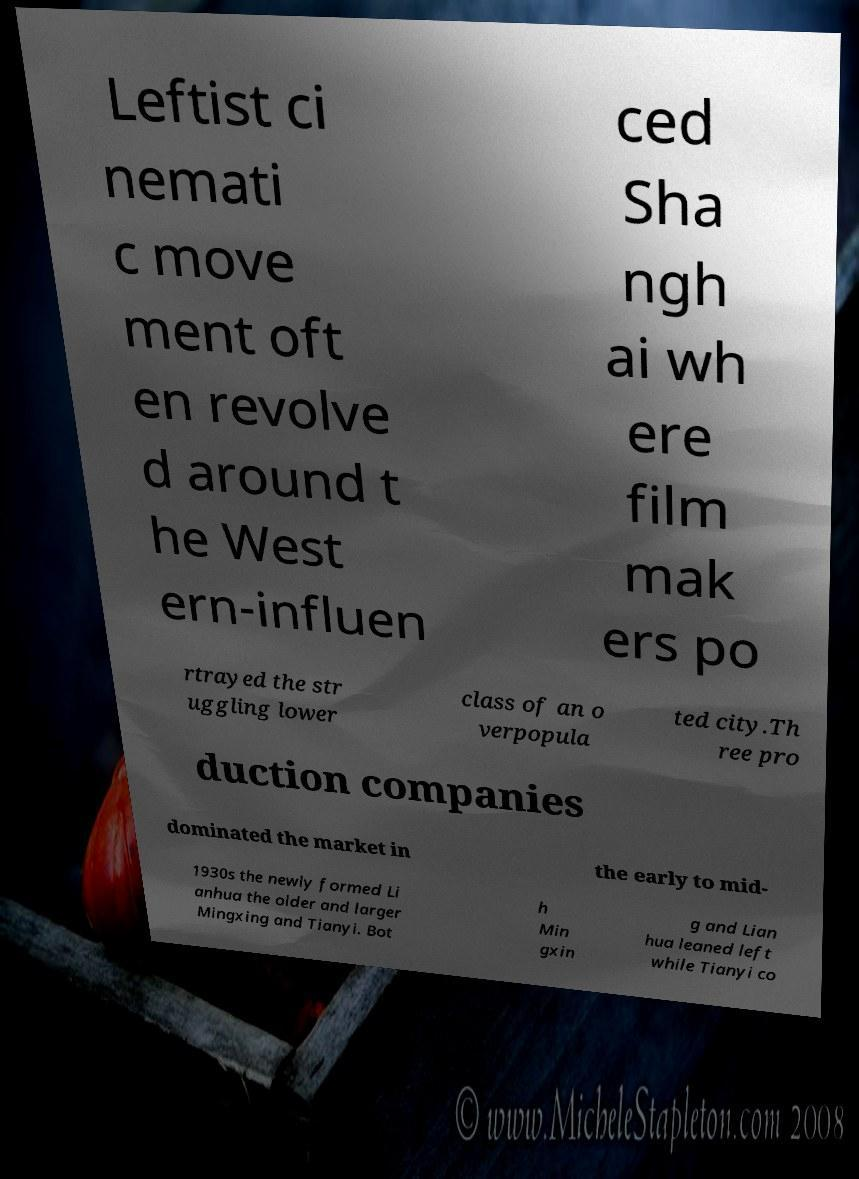Could you assist in decoding the text presented in this image and type it out clearly? Leftist ci nemati c move ment oft en revolve d around t he West ern-influen ced Sha ngh ai wh ere film mak ers po rtrayed the str uggling lower class of an o verpopula ted city.Th ree pro duction companies dominated the market in the early to mid- 1930s the newly formed Li anhua the older and larger Mingxing and Tianyi. Bot h Min gxin g and Lian hua leaned left while Tianyi co 